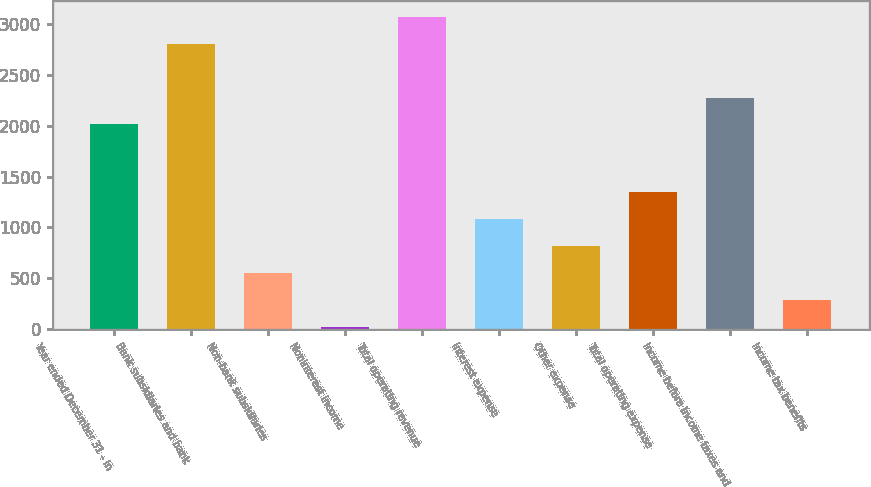Convert chart to OTSL. <chart><loc_0><loc_0><loc_500><loc_500><bar_chart><fcel>Year ended December 31 - in<fcel>Bank subsidiaries and bank<fcel>Non-bank subsidiaries<fcel>Noninterest income<fcel>Total operating revenue<fcel>Interest expense<fcel>Other expense<fcel>Total operating expense<fcel>Income before income taxes and<fcel>Income tax benefits<nl><fcel>2011<fcel>2804.5<fcel>553<fcel>24<fcel>3069<fcel>1082<fcel>817.5<fcel>1346.5<fcel>2275.5<fcel>288.5<nl></chart> 